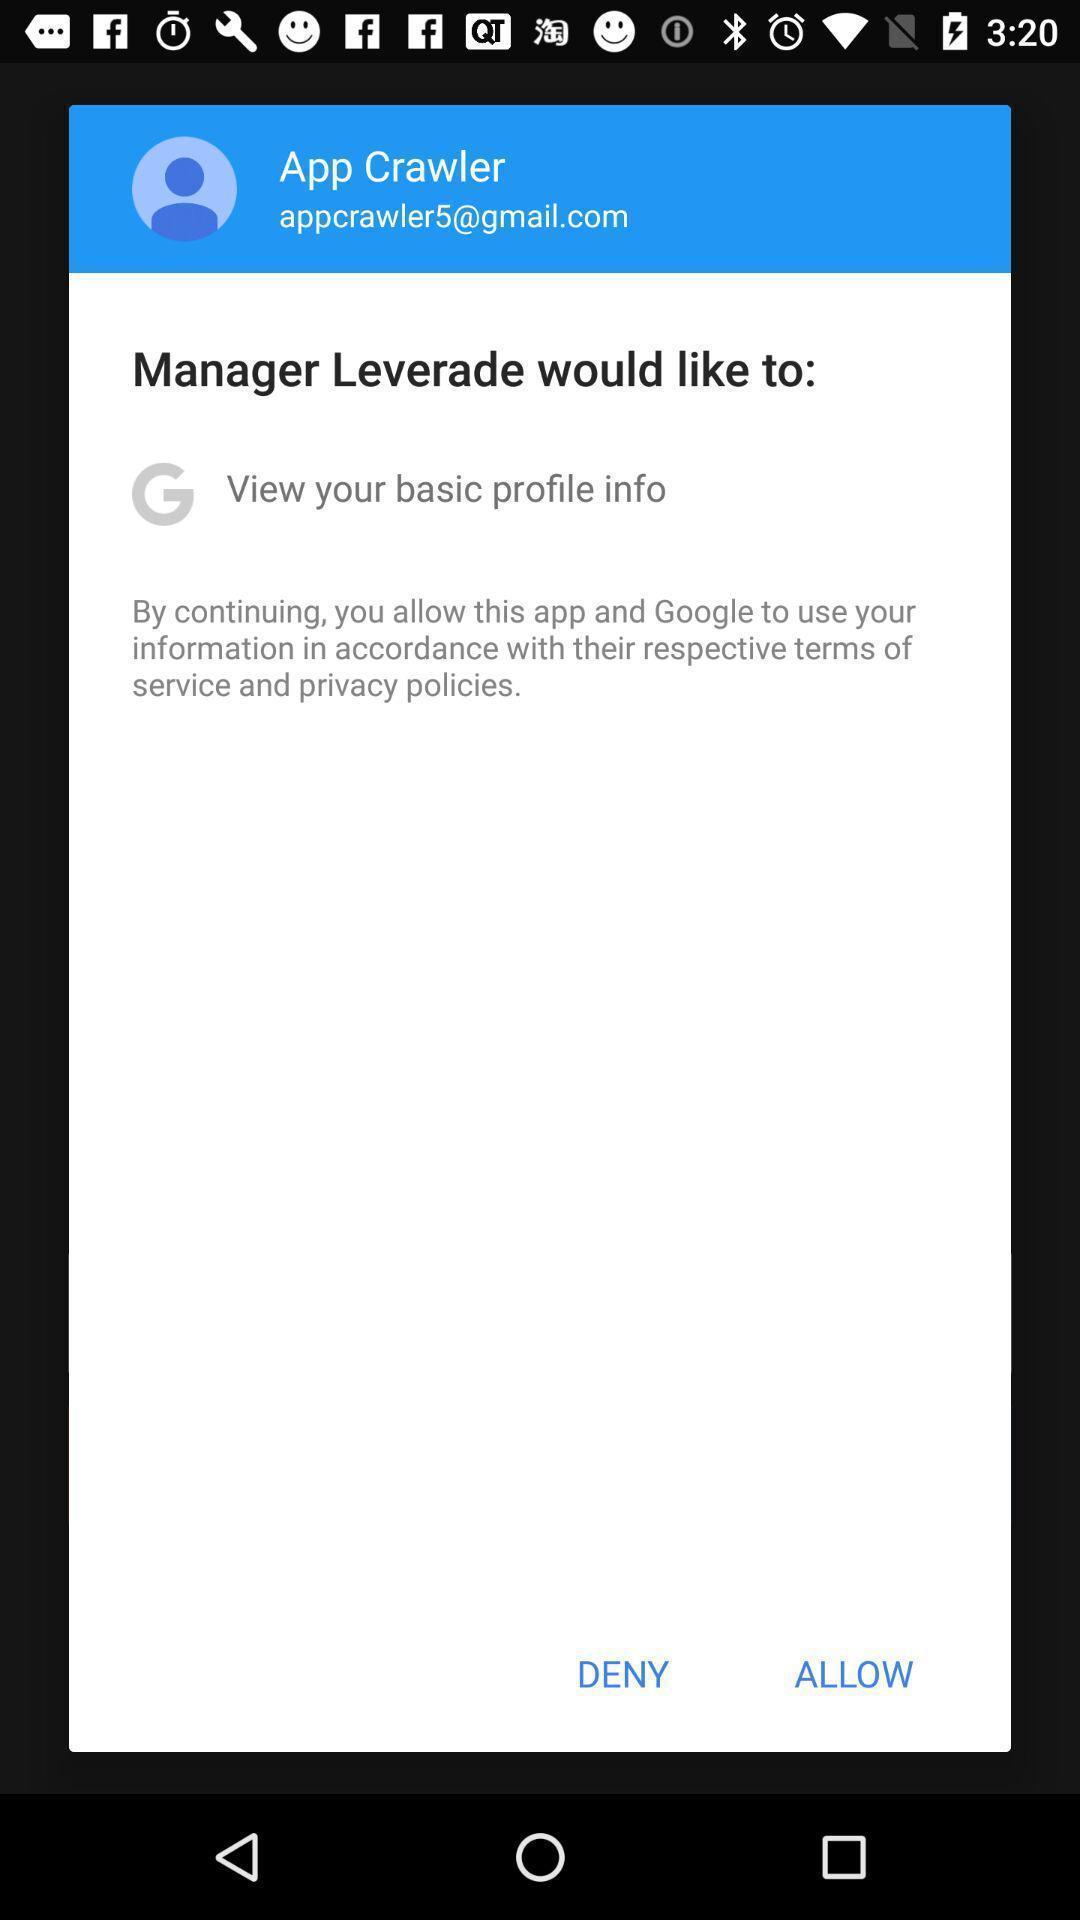Give me a summary of this screen capture. Pop-up window showing a message to allow the access. 